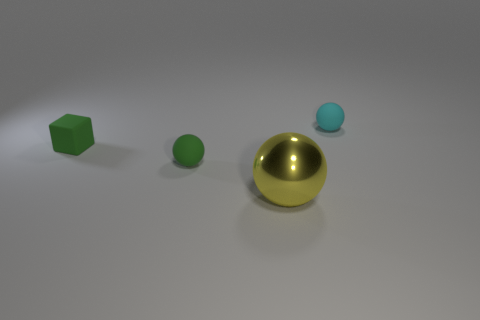What number of rubber objects are either large gray cylinders or small spheres?
Provide a succinct answer. 2. What color is the other metallic object that is the same shape as the tiny cyan thing?
Offer a terse response. Yellow. Are there any small objects?
Offer a terse response. Yes. Is the material of the small object on the right side of the green rubber ball the same as the yellow sphere in front of the green rubber sphere?
Ensure brevity in your answer.  No. How many things are either small objects left of the cyan object or big shiny objects that are to the right of the tiny green matte ball?
Offer a very short reply. 3. There is a small ball to the left of the large yellow metallic object; is its color the same as the object that is on the left side of the tiny green rubber sphere?
Keep it short and to the point. Yes. There is a object that is behind the metallic thing and in front of the block; what shape is it?
Offer a very short reply. Sphere. What is the color of the other sphere that is the same size as the green matte sphere?
Offer a terse response. Cyan. Are there any objects that have the same color as the block?
Your response must be concise. Yes. There is a rubber sphere that is in front of the tiny cyan object; does it have the same size as the ball that is in front of the green sphere?
Give a very brief answer. No. 